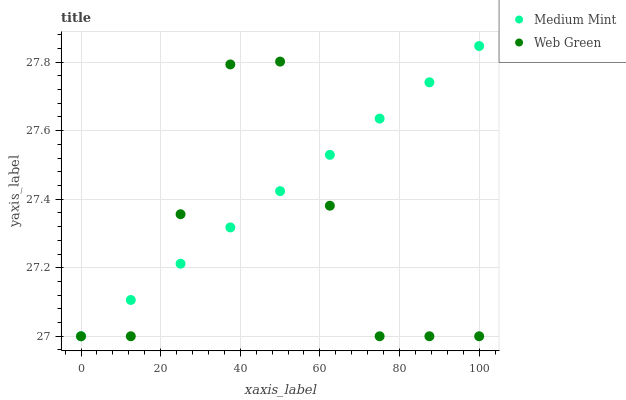Does Web Green have the minimum area under the curve?
Answer yes or no. Yes. Does Medium Mint have the maximum area under the curve?
Answer yes or no. Yes. Does Web Green have the maximum area under the curve?
Answer yes or no. No. Is Medium Mint the smoothest?
Answer yes or no. Yes. Is Web Green the roughest?
Answer yes or no. Yes. Is Web Green the smoothest?
Answer yes or no. No. Does Medium Mint have the lowest value?
Answer yes or no. Yes. Does Medium Mint have the highest value?
Answer yes or no. Yes. Does Web Green have the highest value?
Answer yes or no. No. Does Web Green intersect Medium Mint?
Answer yes or no. Yes. Is Web Green less than Medium Mint?
Answer yes or no. No. Is Web Green greater than Medium Mint?
Answer yes or no. No. 